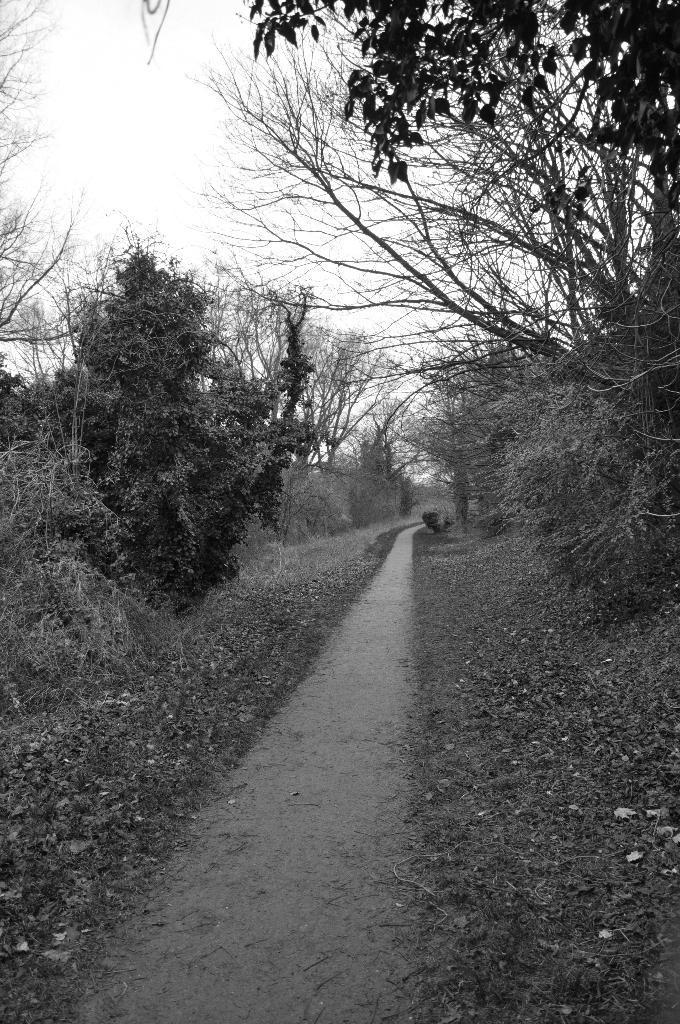Please provide a concise description of this image. This is a black and white image where we can see empty road in the middle, beside that there are so many trees and plants. 